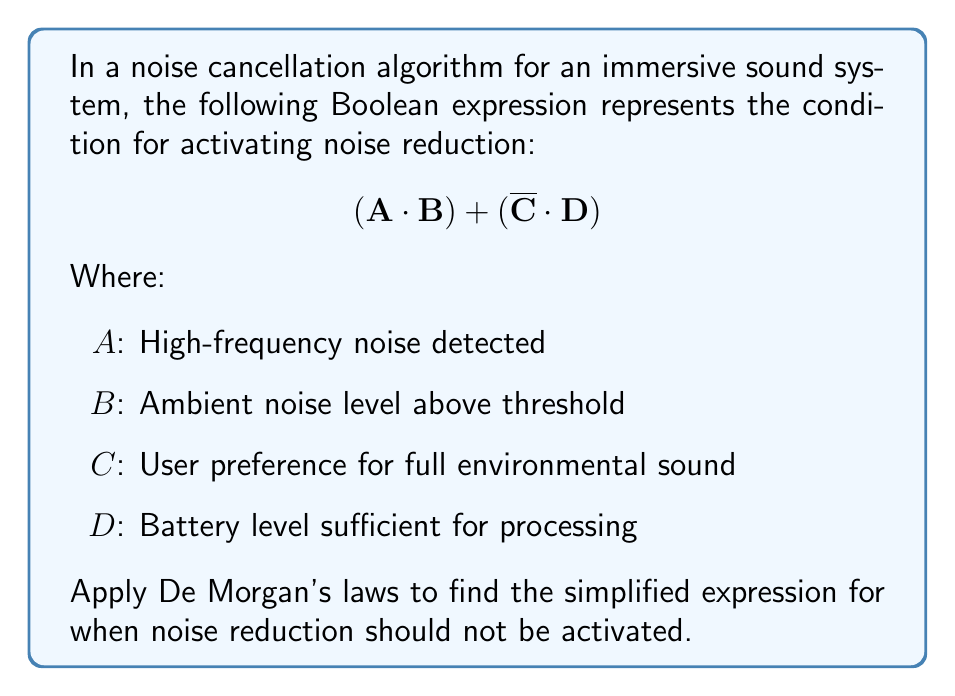Provide a solution to this math problem. To find when noise reduction should not be activated, we need to negate the given expression and simplify it using De Morgan's laws. Let's proceed step-by-step:

1) First, negate the entire expression:
   $$\overline{(A \cdot B) + (\overline{C} \cdot D)}$$

2) Apply De Morgan's first law to the negation of the sum:
   $$\overline{(A \cdot B)} \cdot \overline{(\overline{C} \cdot D)}$$

3) Now apply De Morgan's second law to each term:
   $$(\overline{A} + \overline{B}) \cdot (C + \overline{D})$$

4) Distribute the terms:
   $$(\overline{A} \cdot C) + (\overline{A} \cdot \overline{D}) + (\overline{B} \cdot C) + (\overline{B} \cdot \overline{D})$$

This simplified expression represents when noise reduction should not be activated, which occurs when:
- Either high-frequency noise is not detected AND user prefers full environmental sound, OR
- High-frequency noise is not detected AND battery level is insufficient, OR
- Ambient noise level is below threshold AND user prefers full environmental sound, OR
- Ambient noise level is below threshold AND battery level is insufficient.
Answer: $$(\overline{A} \cdot C) + (\overline{A} \cdot \overline{D}) + (\overline{B} \cdot C) + (\overline{B} \cdot \overline{D})$$ 